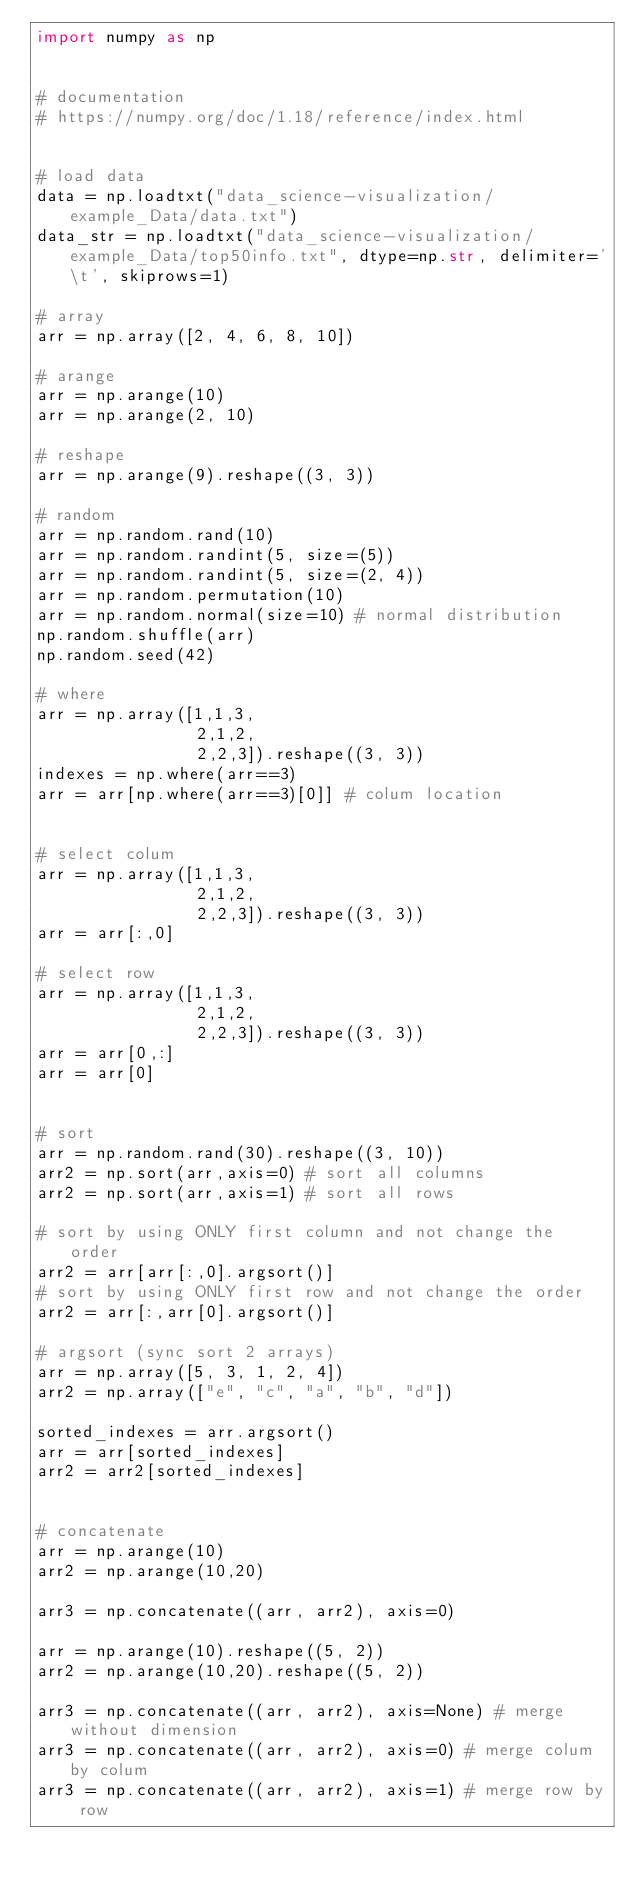Convert code to text. <code><loc_0><loc_0><loc_500><loc_500><_Python_>import numpy as np


# documentation
# https://numpy.org/doc/1.18/reference/index.html


# load data
data = np.loadtxt("data_science-visualization/example_Data/data.txt")
data_str = np.loadtxt("data_science-visualization/example_Data/top50info.txt", dtype=np.str, delimiter='\t', skiprows=1)

# array
arr = np.array([2, 4, 6, 8, 10])

# arange
arr = np.arange(10)
arr = np.arange(2, 10)

# reshape
arr = np.arange(9).reshape((3, 3))

# random
arr = np.random.rand(10)
arr = np.random.randint(5, size=(5))
arr = np.random.randint(5, size=(2, 4))
arr = np.random.permutation(10)
arr = np.random.normal(size=10) # normal distribution
np.random.shuffle(arr)
np.random.seed(42)

# where
arr = np.array([1,1,3,
                2,1,2,
                2,2,3]).reshape((3, 3))
indexes = np.where(arr==3)
arr = arr[np.where(arr==3)[0]] # colum location


# select colum
arr = np.array([1,1,3,
                2,1,2,
                2,2,3]).reshape((3, 3))
arr = arr[:,0]

# select row
arr = np.array([1,1,3,
                2,1,2,
                2,2,3]).reshape((3, 3))
arr = arr[0,:]
arr = arr[0]


# sort
arr = np.random.rand(30).reshape((3, 10))
arr2 = np.sort(arr,axis=0) # sort all columns
arr2 = np.sort(arr,axis=1) # sort all rows

# sort by using ONLY first column and not change the order
arr2 = arr[arr[:,0].argsort()] 
# sort by using ONLY first row and not change the order
arr2 = arr[:,arr[0].argsort()] 

# argsort (sync sort 2 arrays)
arr = np.array([5, 3, 1, 2, 4])
arr2 = np.array(["e", "c", "a", "b", "d"])

sorted_indexes = arr.argsort()
arr = arr[sorted_indexes]
arr2 = arr2[sorted_indexes]


# concatenate
arr = np.arange(10)
arr2 = np.arange(10,20)

arr3 = np.concatenate((arr, arr2), axis=0)

arr = np.arange(10).reshape((5, 2))
arr2 = np.arange(10,20).reshape((5, 2))

arr3 = np.concatenate((arr, arr2), axis=None) # merge without dimension
arr3 = np.concatenate((arr, arr2), axis=0) # merge colum by colum
arr3 = np.concatenate((arr, arr2), axis=1) # merge row by row


</code> 